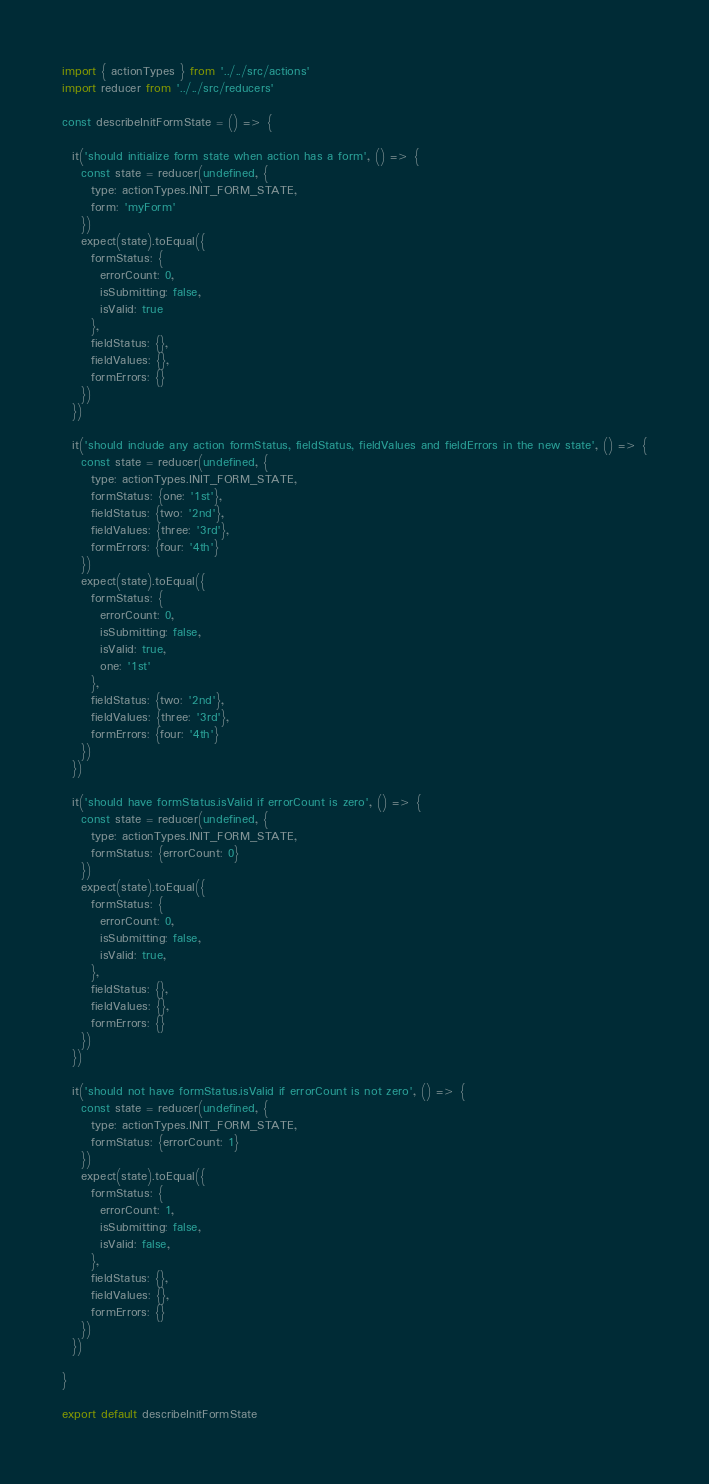<code> <loc_0><loc_0><loc_500><loc_500><_JavaScript_>import { actionTypes } from '../../src/actions'
import reducer from '../../src/reducers'

const describeInitFormState = () => {

  it('should initialize form state when action has a form', () => {
    const state = reducer(undefined, {
      type: actionTypes.INIT_FORM_STATE,
      form: 'myForm'
    })
    expect(state).toEqual({
      formStatus: {
        errorCount: 0,
        isSubmitting: false,
        isValid: true
      },
      fieldStatus: {},
      fieldValues: {},
      formErrors: {}          
    })
  })

  it('should include any action formStatus, fieldStatus, fieldValues and fieldErrors in the new state', () => {
    const state = reducer(undefined, {
      type: actionTypes.INIT_FORM_STATE,
      formStatus: {one: '1st'},
      fieldStatus: {two: '2nd'},
      fieldValues: {three: '3rd'},
      formErrors: {four: '4th'}
    })
    expect(state).toEqual({
      formStatus: {
        errorCount: 0,
        isSubmitting: false,
        isValid: true,
        one: '1st'
      },
      fieldStatus: {two: '2nd'},
      fieldValues: {three: '3rd'},
      formErrors: {four: '4th'}
    })
  })

  it('should have formStatus.isValid if errorCount is zero', () => {
    const state = reducer(undefined, {
      type: actionTypes.INIT_FORM_STATE,
      formStatus: {errorCount: 0}
    })
    expect(state).toEqual({
      formStatus: {
        errorCount: 0,
        isSubmitting: false,
        isValid: true,
      },
      fieldStatus: {},
      fieldValues: {},
      formErrors: {}
    })
  })  

  it('should not have formStatus.isValid if errorCount is not zero', () => {
    const state = reducer(undefined, {
      type: actionTypes.INIT_FORM_STATE,
      formStatus: {errorCount: 1}
    })
    expect(state).toEqual({
      formStatus: {
        errorCount: 1,
        isSubmitting: false,
        isValid: false,
      },
      fieldStatus: {},
      fieldValues: {},
      formErrors: {}
    })
  })  

}

export default describeInitFormState
</code> 